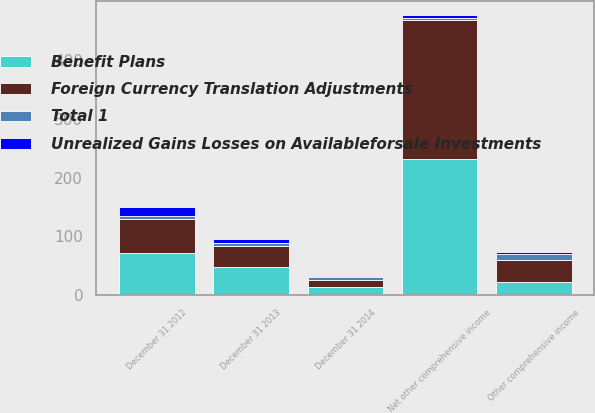Convert chart to OTSL. <chart><loc_0><loc_0><loc_500><loc_500><stacked_bar_chart><ecel><fcel>December 31 2012<fcel>Other comprehensive income<fcel>Net other comprehensive income<fcel>December 31 2013<fcel>December 31 2014<nl><fcel>Unrealized Gains Losses on Availableforsale Investments<fcel>16<fcel>4<fcel>5<fcel>7<fcel>2<nl><fcel>Total 1<fcel>4<fcel>10<fcel>2<fcel>6<fcel>4<nl><fcel>Benefit Plans<fcel>71<fcel>23<fcel>231<fcel>48<fcel>13<nl><fcel>Foreign Currency Translation Adjustments<fcel>59<fcel>37<fcel>238<fcel>35<fcel>13<nl></chart> 